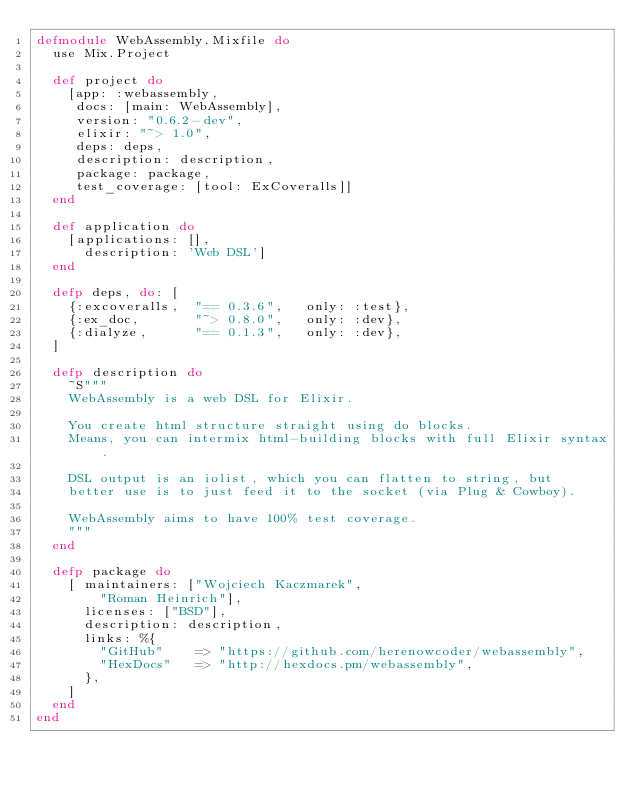Convert code to text. <code><loc_0><loc_0><loc_500><loc_500><_Elixir_>defmodule WebAssembly.Mixfile do
  use Mix.Project

  def project do
    [app: :webassembly,
     docs: [main: WebAssembly],
     version: "0.6.2-dev",
     elixir: "~> 1.0",
     deps: deps,
     description: description,
     package: package,
     test_coverage: [tool: ExCoveralls]]
  end

  def application do
    [applications: [],
      description: 'Web DSL']
  end

  defp deps, do: [
    {:excoveralls,  "== 0.3.6",   only: :test},
    {:ex_doc,       "~> 0.8.0",   only: :dev},
    {:dialyze,      "== 0.1.3",   only: :dev},
  ]

  defp description do
    ~S"""
    WebAssembly is a web DSL for Elixir.

    You create html structure straight using do blocks.
    Means, you can intermix html-building blocks with full Elixir syntax.

    DSL output is an iolist, which you can flatten to string, but
    better use is to just feed it to the socket (via Plug & Cowboy).

    WebAssembly aims to have 100% test coverage.
    """
  end

  defp package do
    [ maintainers: ["Wojciech Kaczmarek",
        "Roman Heinrich"],
      licenses: ["BSD"],
      description: description,
      links: %{
        "GitHub"    => "https://github.com/herenowcoder/webassembly",
        "HexDocs"   => "http://hexdocs.pm/webassembly",
      },
    ]
  end
end
</code> 